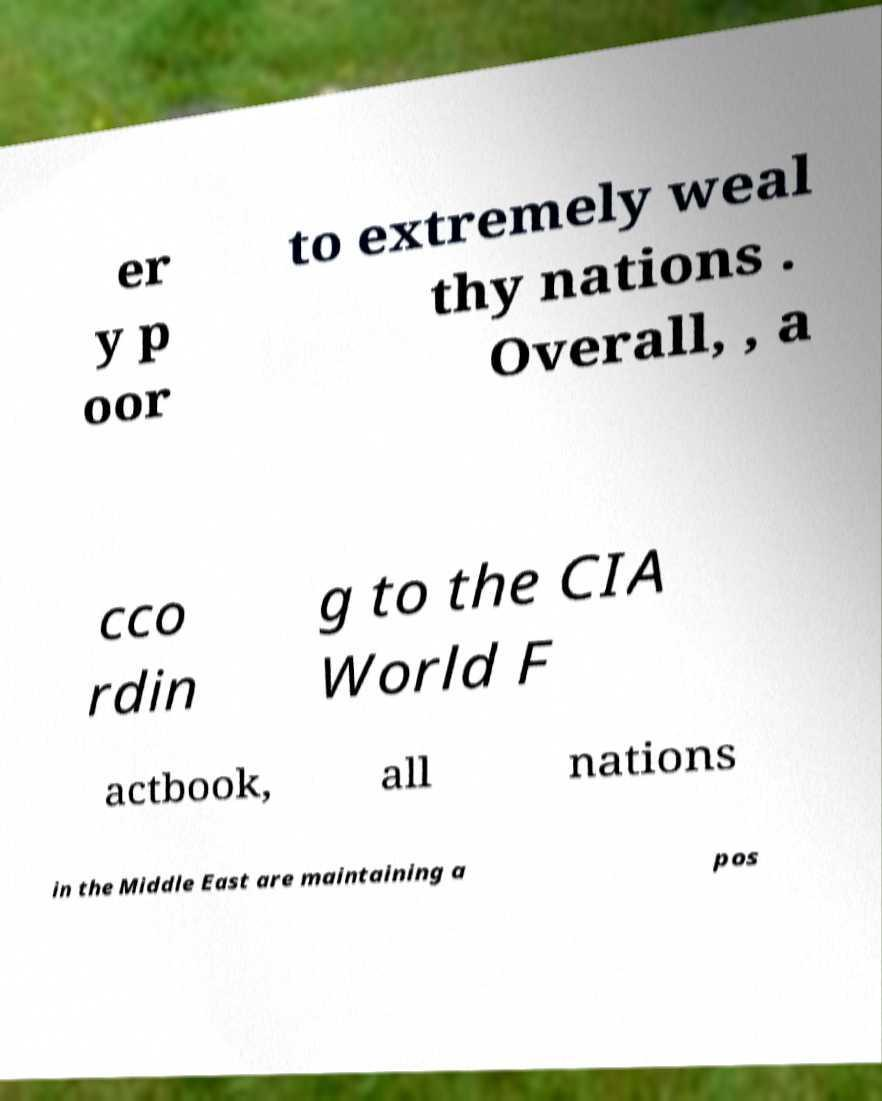Please read and relay the text visible in this image. What does it say? er y p oor to extremely weal thy nations . Overall, , a cco rdin g to the CIA World F actbook, all nations in the Middle East are maintaining a pos 